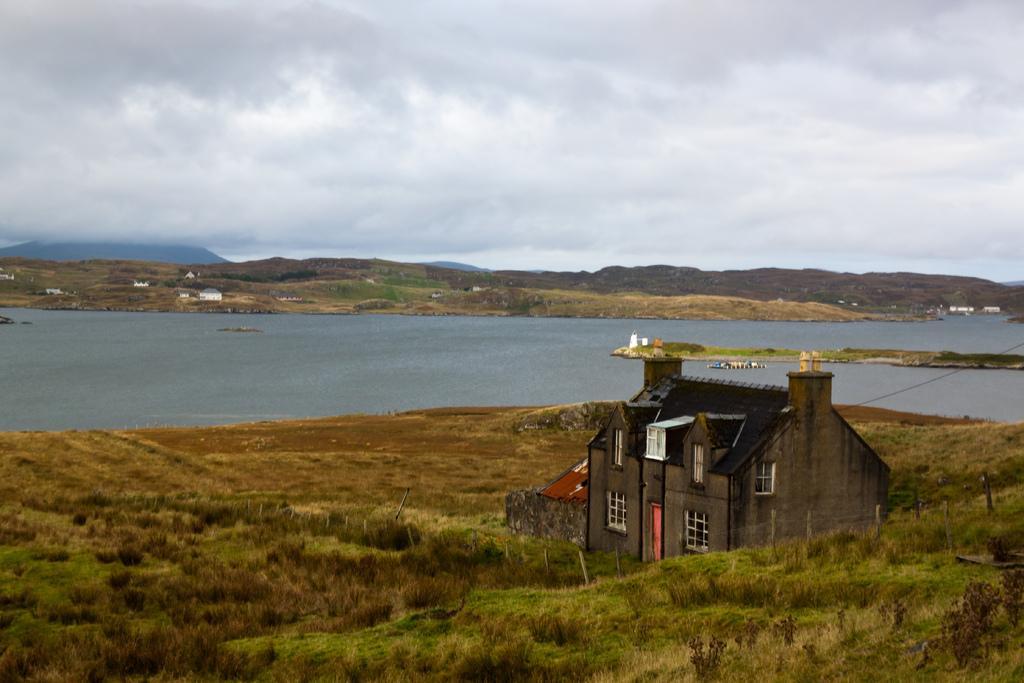Please provide a concise description of this image. There is a house, there are plants, this is water and a sky. 